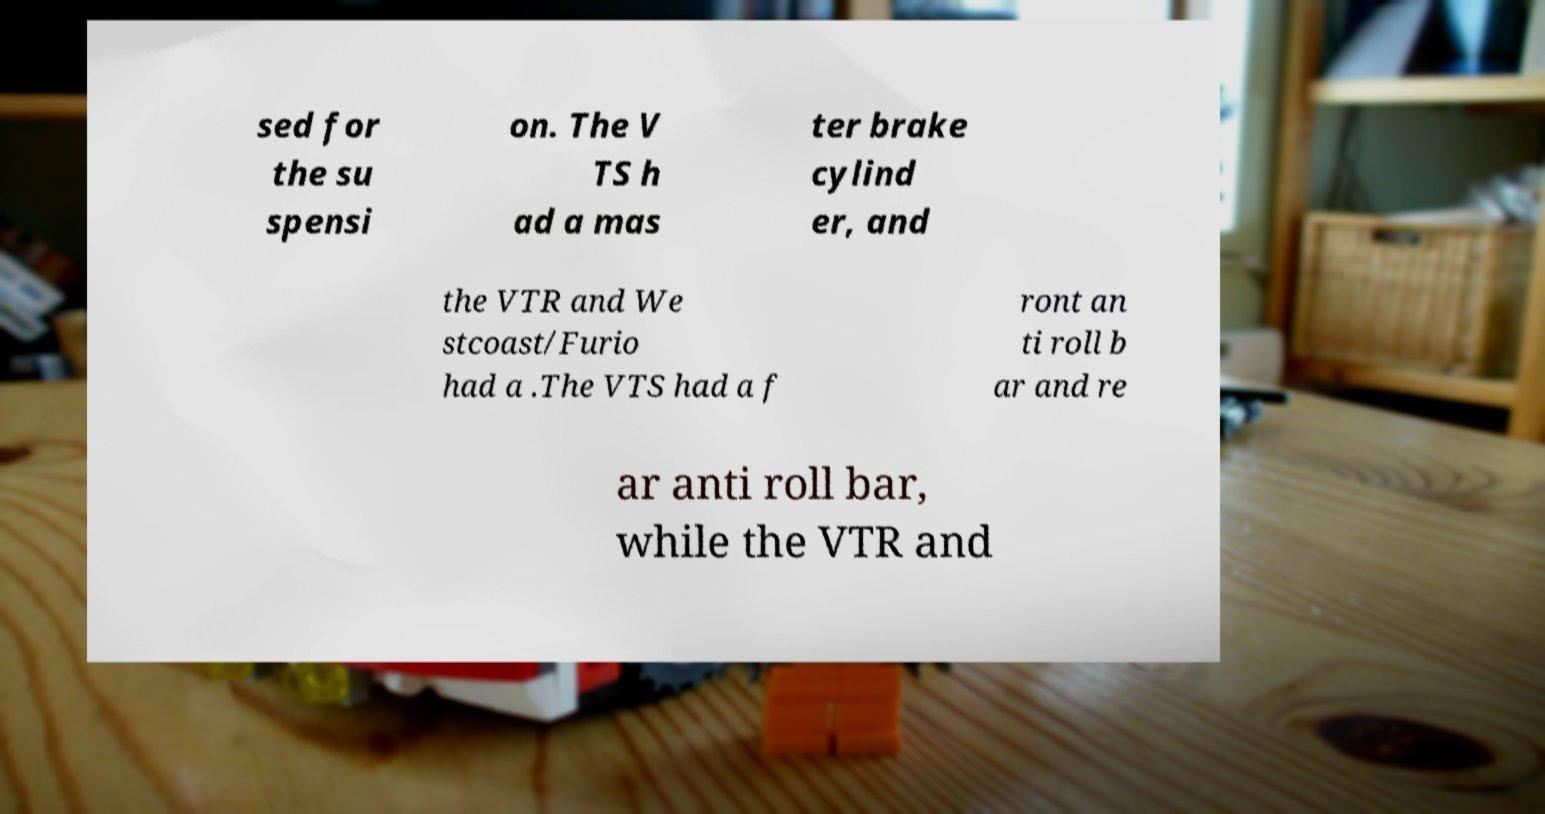Can you accurately transcribe the text from the provided image for me? sed for the su spensi on. The V TS h ad a mas ter brake cylind er, and the VTR and We stcoast/Furio had a .The VTS had a f ront an ti roll b ar and re ar anti roll bar, while the VTR and 